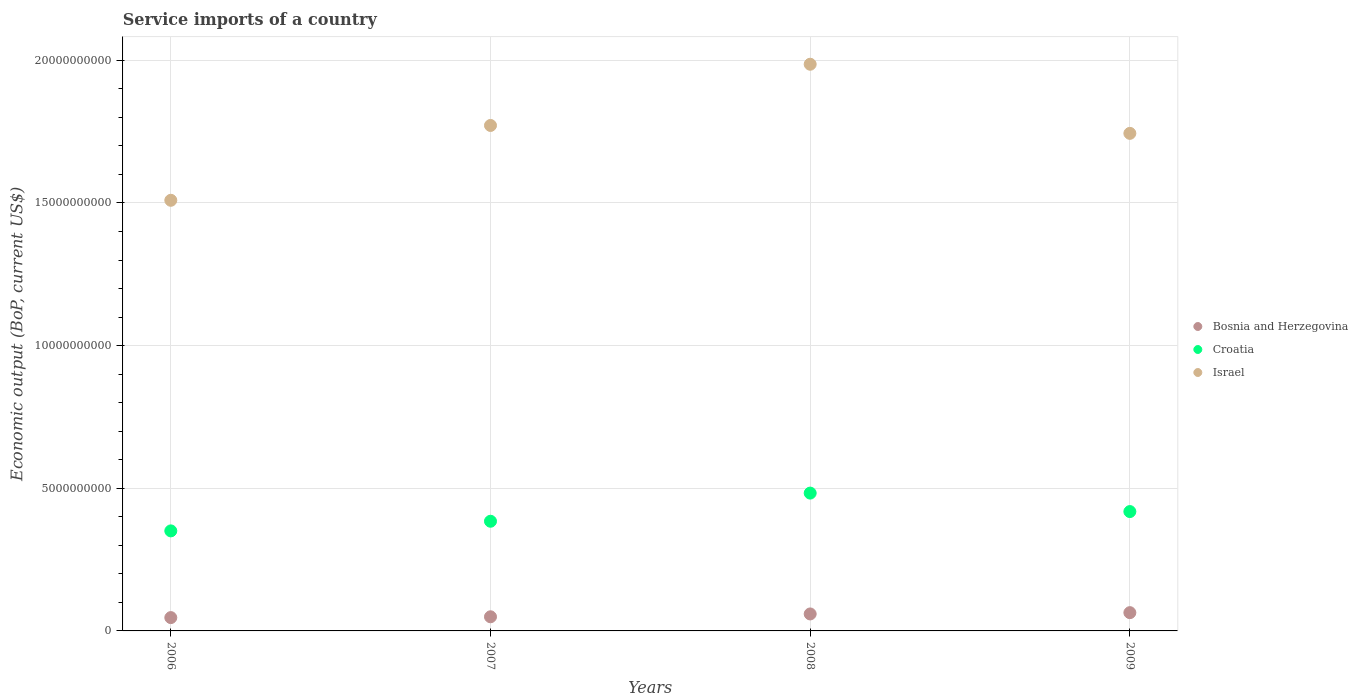How many different coloured dotlines are there?
Keep it short and to the point. 3. What is the service imports in Israel in 2009?
Offer a terse response. 1.74e+1. Across all years, what is the maximum service imports in Bosnia and Herzegovina?
Ensure brevity in your answer.  6.40e+08. Across all years, what is the minimum service imports in Bosnia and Herzegovina?
Make the answer very short. 4.67e+08. What is the total service imports in Bosnia and Herzegovina in the graph?
Offer a very short reply. 2.20e+09. What is the difference between the service imports in Bosnia and Herzegovina in 2006 and that in 2007?
Your response must be concise. -2.86e+07. What is the difference between the service imports in Croatia in 2006 and the service imports in Israel in 2007?
Give a very brief answer. -1.42e+1. What is the average service imports in Croatia per year?
Offer a terse response. 4.09e+09. In the year 2007, what is the difference between the service imports in Israel and service imports in Croatia?
Your answer should be very brief. 1.39e+1. In how many years, is the service imports in Israel greater than 12000000000 US$?
Offer a terse response. 4. What is the ratio of the service imports in Israel in 2007 to that in 2009?
Provide a succinct answer. 1.02. What is the difference between the highest and the second highest service imports in Bosnia and Herzegovina?
Keep it short and to the point. 4.55e+07. What is the difference between the highest and the lowest service imports in Croatia?
Make the answer very short. 1.32e+09. Is it the case that in every year, the sum of the service imports in Bosnia and Herzegovina and service imports in Croatia  is greater than the service imports in Israel?
Provide a succinct answer. No. Is the service imports in Israel strictly greater than the service imports in Croatia over the years?
Keep it short and to the point. Yes. Is the service imports in Croatia strictly less than the service imports in Bosnia and Herzegovina over the years?
Keep it short and to the point. No. How many dotlines are there?
Keep it short and to the point. 3. How many years are there in the graph?
Offer a very short reply. 4. Are the values on the major ticks of Y-axis written in scientific E-notation?
Your answer should be very brief. No. Does the graph contain grids?
Provide a succinct answer. Yes. How many legend labels are there?
Your answer should be very brief. 3. What is the title of the graph?
Provide a short and direct response. Service imports of a country. Does "Cote d'Ivoire" appear as one of the legend labels in the graph?
Offer a very short reply. No. What is the label or title of the X-axis?
Ensure brevity in your answer.  Years. What is the label or title of the Y-axis?
Ensure brevity in your answer.  Economic output (BoP, current US$). What is the Economic output (BoP, current US$) of Bosnia and Herzegovina in 2006?
Provide a succinct answer. 4.67e+08. What is the Economic output (BoP, current US$) of Croatia in 2006?
Make the answer very short. 3.51e+09. What is the Economic output (BoP, current US$) in Israel in 2006?
Keep it short and to the point. 1.51e+1. What is the Economic output (BoP, current US$) in Bosnia and Herzegovina in 2007?
Offer a terse response. 4.95e+08. What is the Economic output (BoP, current US$) in Croatia in 2007?
Your answer should be very brief. 3.84e+09. What is the Economic output (BoP, current US$) in Israel in 2007?
Your answer should be compact. 1.77e+1. What is the Economic output (BoP, current US$) in Bosnia and Herzegovina in 2008?
Offer a terse response. 5.95e+08. What is the Economic output (BoP, current US$) in Croatia in 2008?
Provide a succinct answer. 4.83e+09. What is the Economic output (BoP, current US$) in Israel in 2008?
Your answer should be compact. 1.99e+1. What is the Economic output (BoP, current US$) of Bosnia and Herzegovina in 2009?
Ensure brevity in your answer.  6.40e+08. What is the Economic output (BoP, current US$) of Croatia in 2009?
Give a very brief answer. 4.18e+09. What is the Economic output (BoP, current US$) in Israel in 2009?
Offer a terse response. 1.74e+1. Across all years, what is the maximum Economic output (BoP, current US$) of Bosnia and Herzegovina?
Offer a terse response. 6.40e+08. Across all years, what is the maximum Economic output (BoP, current US$) of Croatia?
Provide a short and direct response. 4.83e+09. Across all years, what is the maximum Economic output (BoP, current US$) in Israel?
Offer a very short reply. 1.99e+1. Across all years, what is the minimum Economic output (BoP, current US$) in Bosnia and Herzegovina?
Offer a terse response. 4.67e+08. Across all years, what is the minimum Economic output (BoP, current US$) in Croatia?
Your response must be concise. 3.51e+09. Across all years, what is the minimum Economic output (BoP, current US$) in Israel?
Ensure brevity in your answer.  1.51e+1. What is the total Economic output (BoP, current US$) of Bosnia and Herzegovina in the graph?
Make the answer very short. 2.20e+09. What is the total Economic output (BoP, current US$) in Croatia in the graph?
Provide a succinct answer. 1.64e+1. What is the total Economic output (BoP, current US$) of Israel in the graph?
Provide a succinct answer. 7.01e+1. What is the difference between the Economic output (BoP, current US$) of Bosnia and Herzegovina in 2006 and that in 2007?
Your answer should be very brief. -2.86e+07. What is the difference between the Economic output (BoP, current US$) in Croatia in 2006 and that in 2007?
Ensure brevity in your answer.  -3.38e+08. What is the difference between the Economic output (BoP, current US$) in Israel in 2006 and that in 2007?
Make the answer very short. -2.62e+09. What is the difference between the Economic output (BoP, current US$) in Bosnia and Herzegovina in 2006 and that in 2008?
Your response must be concise. -1.28e+08. What is the difference between the Economic output (BoP, current US$) of Croatia in 2006 and that in 2008?
Give a very brief answer. -1.32e+09. What is the difference between the Economic output (BoP, current US$) in Israel in 2006 and that in 2008?
Provide a short and direct response. -4.77e+09. What is the difference between the Economic output (BoP, current US$) of Bosnia and Herzegovina in 2006 and that in 2009?
Your answer should be compact. -1.74e+08. What is the difference between the Economic output (BoP, current US$) in Croatia in 2006 and that in 2009?
Ensure brevity in your answer.  -6.77e+08. What is the difference between the Economic output (BoP, current US$) in Israel in 2006 and that in 2009?
Your answer should be compact. -2.35e+09. What is the difference between the Economic output (BoP, current US$) of Bosnia and Herzegovina in 2007 and that in 2008?
Your answer should be compact. -9.97e+07. What is the difference between the Economic output (BoP, current US$) in Croatia in 2007 and that in 2008?
Your response must be concise. -9.87e+08. What is the difference between the Economic output (BoP, current US$) in Israel in 2007 and that in 2008?
Give a very brief answer. -2.15e+09. What is the difference between the Economic output (BoP, current US$) of Bosnia and Herzegovina in 2007 and that in 2009?
Offer a terse response. -1.45e+08. What is the difference between the Economic output (BoP, current US$) of Croatia in 2007 and that in 2009?
Your answer should be very brief. -3.39e+08. What is the difference between the Economic output (BoP, current US$) in Israel in 2007 and that in 2009?
Your answer should be very brief. 2.77e+08. What is the difference between the Economic output (BoP, current US$) in Bosnia and Herzegovina in 2008 and that in 2009?
Offer a very short reply. -4.55e+07. What is the difference between the Economic output (BoP, current US$) in Croatia in 2008 and that in 2009?
Provide a short and direct response. 6.48e+08. What is the difference between the Economic output (BoP, current US$) in Israel in 2008 and that in 2009?
Keep it short and to the point. 2.42e+09. What is the difference between the Economic output (BoP, current US$) of Bosnia and Herzegovina in 2006 and the Economic output (BoP, current US$) of Croatia in 2007?
Give a very brief answer. -3.38e+09. What is the difference between the Economic output (BoP, current US$) of Bosnia and Herzegovina in 2006 and the Economic output (BoP, current US$) of Israel in 2007?
Give a very brief answer. -1.73e+1. What is the difference between the Economic output (BoP, current US$) of Croatia in 2006 and the Economic output (BoP, current US$) of Israel in 2007?
Your answer should be compact. -1.42e+1. What is the difference between the Economic output (BoP, current US$) of Bosnia and Herzegovina in 2006 and the Economic output (BoP, current US$) of Croatia in 2008?
Your answer should be compact. -4.36e+09. What is the difference between the Economic output (BoP, current US$) in Bosnia and Herzegovina in 2006 and the Economic output (BoP, current US$) in Israel in 2008?
Offer a very short reply. -1.94e+1. What is the difference between the Economic output (BoP, current US$) of Croatia in 2006 and the Economic output (BoP, current US$) of Israel in 2008?
Provide a succinct answer. -1.64e+1. What is the difference between the Economic output (BoP, current US$) in Bosnia and Herzegovina in 2006 and the Economic output (BoP, current US$) in Croatia in 2009?
Provide a succinct answer. -3.72e+09. What is the difference between the Economic output (BoP, current US$) of Bosnia and Herzegovina in 2006 and the Economic output (BoP, current US$) of Israel in 2009?
Your answer should be very brief. -1.70e+1. What is the difference between the Economic output (BoP, current US$) of Croatia in 2006 and the Economic output (BoP, current US$) of Israel in 2009?
Your answer should be compact. -1.39e+1. What is the difference between the Economic output (BoP, current US$) of Bosnia and Herzegovina in 2007 and the Economic output (BoP, current US$) of Croatia in 2008?
Your response must be concise. -4.34e+09. What is the difference between the Economic output (BoP, current US$) of Bosnia and Herzegovina in 2007 and the Economic output (BoP, current US$) of Israel in 2008?
Offer a terse response. -1.94e+1. What is the difference between the Economic output (BoP, current US$) in Croatia in 2007 and the Economic output (BoP, current US$) in Israel in 2008?
Ensure brevity in your answer.  -1.60e+1. What is the difference between the Economic output (BoP, current US$) in Bosnia and Herzegovina in 2007 and the Economic output (BoP, current US$) in Croatia in 2009?
Your response must be concise. -3.69e+09. What is the difference between the Economic output (BoP, current US$) in Bosnia and Herzegovina in 2007 and the Economic output (BoP, current US$) in Israel in 2009?
Provide a succinct answer. -1.69e+1. What is the difference between the Economic output (BoP, current US$) in Croatia in 2007 and the Economic output (BoP, current US$) in Israel in 2009?
Your response must be concise. -1.36e+1. What is the difference between the Economic output (BoP, current US$) of Bosnia and Herzegovina in 2008 and the Economic output (BoP, current US$) of Croatia in 2009?
Provide a short and direct response. -3.59e+09. What is the difference between the Economic output (BoP, current US$) in Bosnia and Herzegovina in 2008 and the Economic output (BoP, current US$) in Israel in 2009?
Offer a terse response. -1.68e+1. What is the difference between the Economic output (BoP, current US$) of Croatia in 2008 and the Economic output (BoP, current US$) of Israel in 2009?
Keep it short and to the point. -1.26e+1. What is the average Economic output (BoP, current US$) of Bosnia and Herzegovina per year?
Your answer should be compact. 5.49e+08. What is the average Economic output (BoP, current US$) in Croatia per year?
Keep it short and to the point. 4.09e+09. What is the average Economic output (BoP, current US$) in Israel per year?
Keep it short and to the point. 1.75e+1. In the year 2006, what is the difference between the Economic output (BoP, current US$) of Bosnia and Herzegovina and Economic output (BoP, current US$) of Croatia?
Your answer should be very brief. -3.04e+09. In the year 2006, what is the difference between the Economic output (BoP, current US$) in Bosnia and Herzegovina and Economic output (BoP, current US$) in Israel?
Give a very brief answer. -1.46e+1. In the year 2006, what is the difference between the Economic output (BoP, current US$) of Croatia and Economic output (BoP, current US$) of Israel?
Ensure brevity in your answer.  -1.16e+1. In the year 2007, what is the difference between the Economic output (BoP, current US$) of Bosnia and Herzegovina and Economic output (BoP, current US$) of Croatia?
Make the answer very short. -3.35e+09. In the year 2007, what is the difference between the Economic output (BoP, current US$) in Bosnia and Herzegovina and Economic output (BoP, current US$) in Israel?
Your answer should be compact. -1.72e+1. In the year 2007, what is the difference between the Economic output (BoP, current US$) of Croatia and Economic output (BoP, current US$) of Israel?
Provide a succinct answer. -1.39e+1. In the year 2008, what is the difference between the Economic output (BoP, current US$) in Bosnia and Herzegovina and Economic output (BoP, current US$) in Croatia?
Offer a very short reply. -4.24e+09. In the year 2008, what is the difference between the Economic output (BoP, current US$) in Bosnia and Herzegovina and Economic output (BoP, current US$) in Israel?
Your answer should be compact. -1.93e+1. In the year 2008, what is the difference between the Economic output (BoP, current US$) in Croatia and Economic output (BoP, current US$) in Israel?
Provide a short and direct response. -1.50e+1. In the year 2009, what is the difference between the Economic output (BoP, current US$) in Bosnia and Herzegovina and Economic output (BoP, current US$) in Croatia?
Make the answer very short. -3.54e+09. In the year 2009, what is the difference between the Economic output (BoP, current US$) in Bosnia and Herzegovina and Economic output (BoP, current US$) in Israel?
Make the answer very short. -1.68e+1. In the year 2009, what is the difference between the Economic output (BoP, current US$) in Croatia and Economic output (BoP, current US$) in Israel?
Offer a very short reply. -1.33e+1. What is the ratio of the Economic output (BoP, current US$) of Bosnia and Herzegovina in 2006 to that in 2007?
Make the answer very short. 0.94. What is the ratio of the Economic output (BoP, current US$) of Croatia in 2006 to that in 2007?
Offer a very short reply. 0.91. What is the ratio of the Economic output (BoP, current US$) in Israel in 2006 to that in 2007?
Provide a short and direct response. 0.85. What is the ratio of the Economic output (BoP, current US$) of Bosnia and Herzegovina in 2006 to that in 2008?
Give a very brief answer. 0.78. What is the ratio of the Economic output (BoP, current US$) of Croatia in 2006 to that in 2008?
Your answer should be very brief. 0.73. What is the ratio of the Economic output (BoP, current US$) of Israel in 2006 to that in 2008?
Your answer should be very brief. 0.76. What is the ratio of the Economic output (BoP, current US$) in Bosnia and Herzegovina in 2006 to that in 2009?
Provide a succinct answer. 0.73. What is the ratio of the Economic output (BoP, current US$) of Croatia in 2006 to that in 2009?
Your answer should be compact. 0.84. What is the ratio of the Economic output (BoP, current US$) of Israel in 2006 to that in 2009?
Provide a short and direct response. 0.87. What is the ratio of the Economic output (BoP, current US$) of Bosnia and Herzegovina in 2007 to that in 2008?
Ensure brevity in your answer.  0.83. What is the ratio of the Economic output (BoP, current US$) of Croatia in 2007 to that in 2008?
Your response must be concise. 0.8. What is the ratio of the Economic output (BoP, current US$) in Israel in 2007 to that in 2008?
Your answer should be compact. 0.89. What is the ratio of the Economic output (BoP, current US$) in Bosnia and Herzegovina in 2007 to that in 2009?
Keep it short and to the point. 0.77. What is the ratio of the Economic output (BoP, current US$) in Croatia in 2007 to that in 2009?
Provide a short and direct response. 0.92. What is the ratio of the Economic output (BoP, current US$) of Israel in 2007 to that in 2009?
Provide a short and direct response. 1.02. What is the ratio of the Economic output (BoP, current US$) of Bosnia and Herzegovina in 2008 to that in 2009?
Make the answer very short. 0.93. What is the ratio of the Economic output (BoP, current US$) of Croatia in 2008 to that in 2009?
Offer a very short reply. 1.15. What is the ratio of the Economic output (BoP, current US$) in Israel in 2008 to that in 2009?
Your answer should be very brief. 1.14. What is the difference between the highest and the second highest Economic output (BoP, current US$) of Bosnia and Herzegovina?
Provide a succinct answer. 4.55e+07. What is the difference between the highest and the second highest Economic output (BoP, current US$) of Croatia?
Provide a short and direct response. 6.48e+08. What is the difference between the highest and the second highest Economic output (BoP, current US$) of Israel?
Your answer should be very brief. 2.15e+09. What is the difference between the highest and the lowest Economic output (BoP, current US$) of Bosnia and Herzegovina?
Your answer should be compact. 1.74e+08. What is the difference between the highest and the lowest Economic output (BoP, current US$) in Croatia?
Give a very brief answer. 1.32e+09. What is the difference between the highest and the lowest Economic output (BoP, current US$) in Israel?
Give a very brief answer. 4.77e+09. 